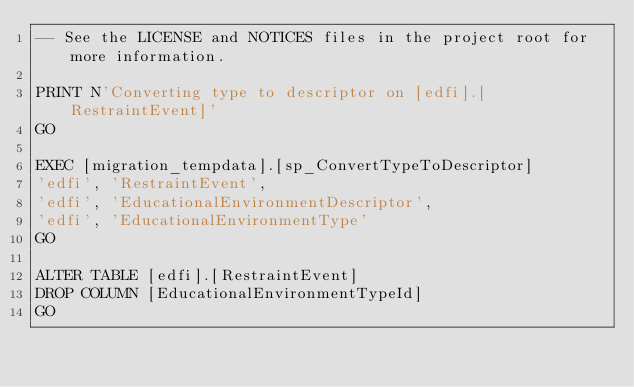Convert code to text. <code><loc_0><loc_0><loc_500><loc_500><_SQL_>-- See the LICENSE and NOTICES files in the project root for more information.

PRINT N'Converting type to descriptor on [edfi].[RestraintEvent]'
GO

EXEC [migration_tempdata].[sp_ConvertTypeToDescriptor]
'edfi', 'RestraintEvent',
'edfi', 'EducationalEnvironmentDescriptor',
'edfi', 'EducationalEnvironmentType'
GO

ALTER TABLE [edfi].[RestraintEvent]
DROP COLUMN [EducationalEnvironmentTypeId]
GO
</code> 